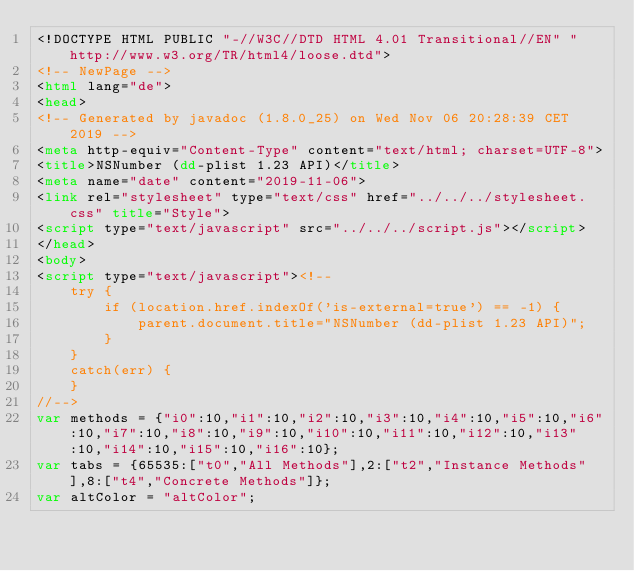<code> <loc_0><loc_0><loc_500><loc_500><_HTML_><!DOCTYPE HTML PUBLIC "-//W3C//DTD HTML 4.01 Transitional//EN" "http://www.w3.org/TR/html4/loose.dtd">
<!-- NewPage -->
<html lang="de">
<head>
<!-- Generated by javadoc (1.8.0_25) on Wed Nov 06 20:28:39 CET 2019 -->
<meta http-equiv="Content-Type" content="text/html; charset=UTF-8">
<title>NSNumber (dd-plist 1.23 API)</title>
<meta name="date" content="2019-11-06">
<link rel="stylesheet" type="text/css" href="../../../stylesheet.css" title="Style">
<script type="text/javascript" src="../../../script.js"></script>
</head>
<body>
<script type="text/javascript"><!--
    try {
        if (location.href.indexOf('is-external=true') == -1) {
            parent.document.title="NSNumber (dd-plist 1.23 API)";
        }
    }
    catch(err) {
    }
//-->
var methods = {"i0":10,"i1":10,"i2":10,"i3":10,"i4":10,"i5":10,"i6":10,"i7":10,"i8":10,"i9":10,"i10":10,"i11":10,"i12":10,"i13":10,"i14":10,"i15":10,"i16":10};
var tabs = {65535:["t0","All Methods"],2:["t2","Instance Methods"],8:["t4","Concrete Methods"]};
var altColor = "altColor";</code> 